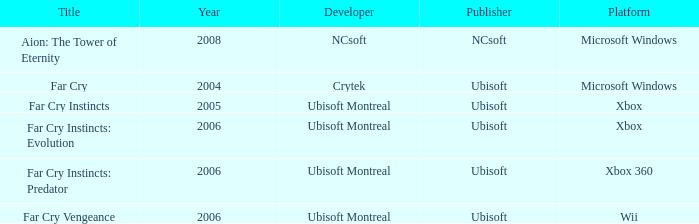Which publisher has Far Cry as the title? Ubisoft. 